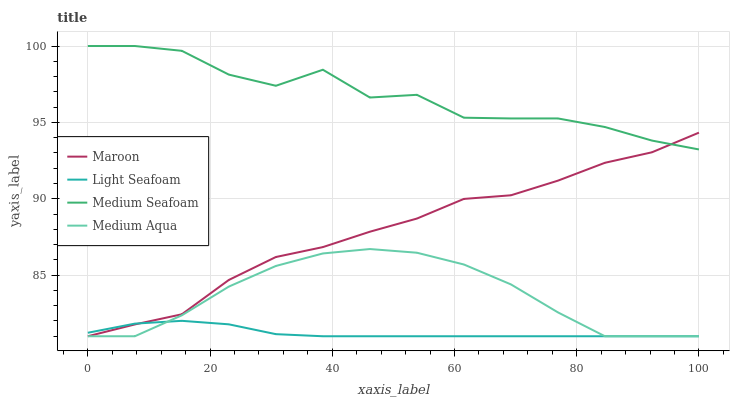Does Light Seafoam have the minimum area under the curve?
Answer yes or no. Yes. Does Medium Seafoam have the maximum area under the curve?
Answer yes or no. Yes. Does Medium Aqua have the minimum area under the curve?
Answer yes or no. No. Does Medium Aqua have the maximum area under the curve?
Answer yes or no. No. Is Light Seafoam the smoothest?
Answer yes or no. Yes. Is Medium Seafoam the roughest?
Answer yes or no. Yes. Is Medium Aqua the smoothest?
Answer yes or no. No. Is Medium Aqua the roughest?
Answer yes or no. No. Does Light Seafoam have the lowest value?
Answer yes or no. Yes. Does Medium Seafoam have the lowest value?
Answer yes or no. No. Does Medium Seafoam have the highest value?
Answer yes or no. Yes. Does Medium Aqua have the highest value?
Answer yes or no. No. Is Medium Aqua less than Medium Seafoam?
Answer yes or no. Yes. Is Medium Seafoam greater than Medium Aqua?
Answer yes or no. Yes. Does Medium Aqua intersect Light Seafoam?
Answer yes or no. Yes. Is Medium Aqua less than Light Seafoam?
Answer yes or no. No. Is Medium Aqua greater than Light Seafoam?
Answer yes or no. No. Does Medium Aqua intersect Medium Seafoam?
Answer yes or no. No. 